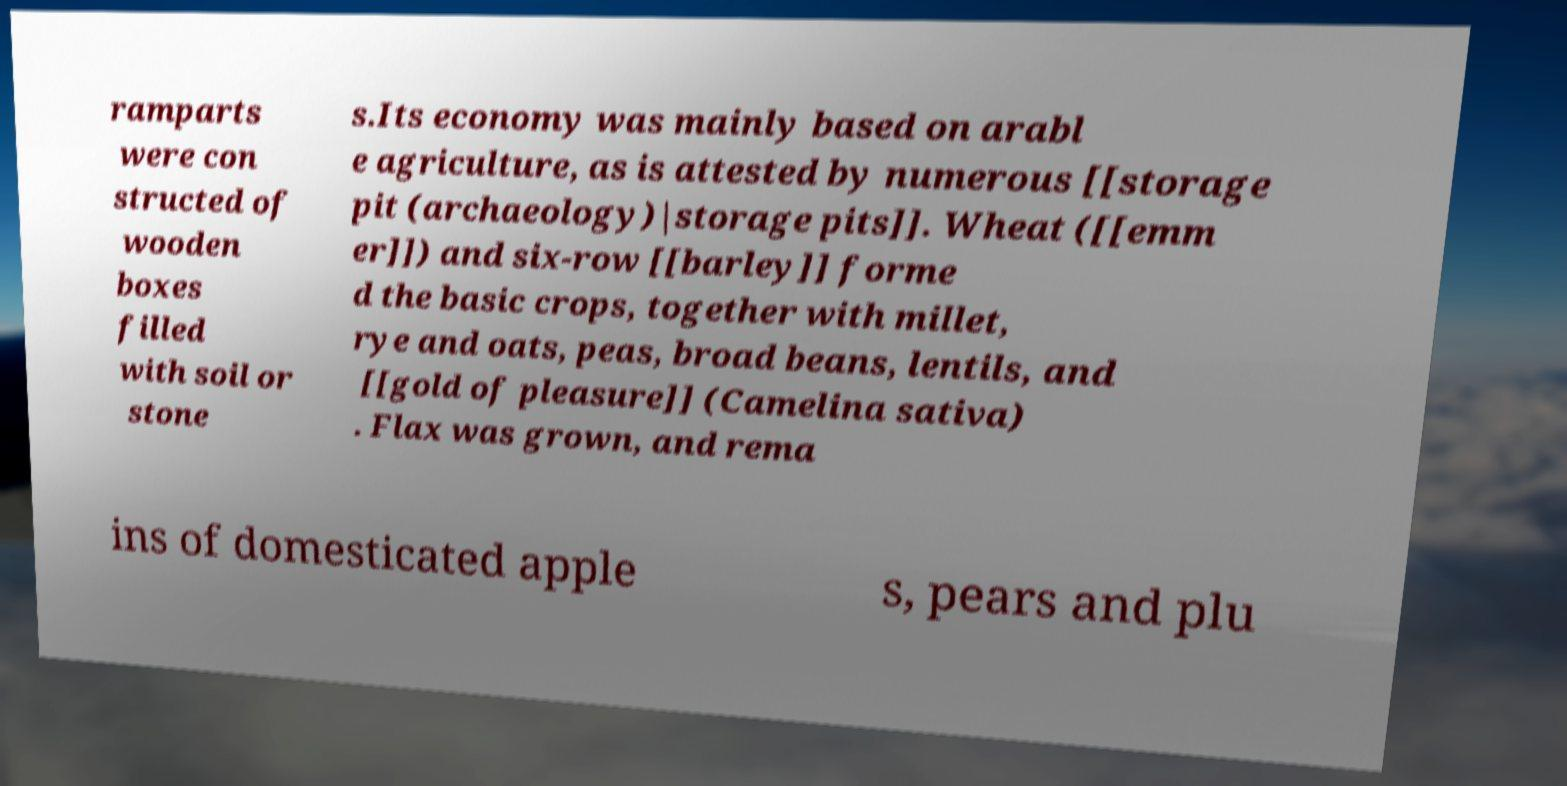Could you extract and type out the text from this image? ramparts were con structed of wooden boxes filled with soil or stone s.Its economy was mainly based on arabl e agriculture, as is attested by numerous [[storage pit (archaeology)|storage pits]]. Wheat ([[emm er]]) and six-row [[barley]] forme d the basic crops, together with millet, rye and oats, peas, broad beans, lentils, and [[gold of pleasure]] (Camelina sativa) . Flax was grown, and rema ins of domesticated apple s, pears and plu 